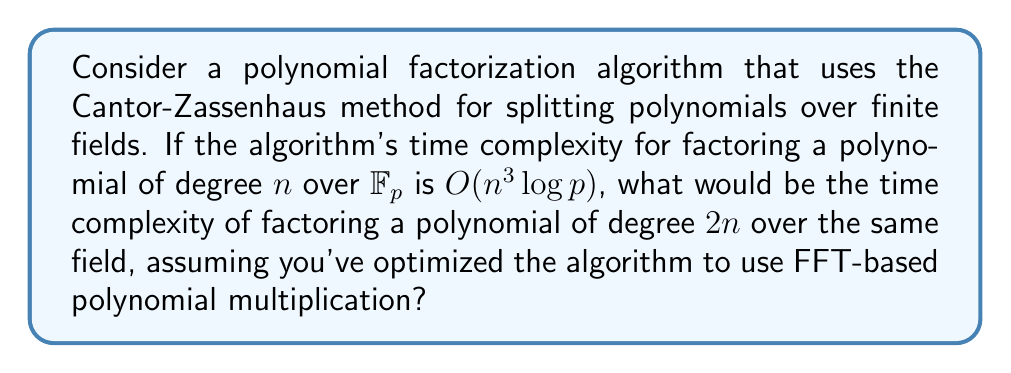What is the answer to this math problem? Let's approach this step-by-step:

1) The original time complexity is $O(n^3 \log p)$ for a polynomial of degree $n$.

2) When we double the degree to $2n$, we need to consider how this affects each part of the algorithm:

   a) The number of iterations in the Cantor-Zassenhaus method is proportional to the degree, so this factor becomes $2n$.

   b) Each iteration involves polynomial arithmetic, primarily multiplication and division.

3) The key optimization mentioned is the use of FFT-based polynomial multiplication. This reduces the complexity of polynomial multiplication from $O(n^2)$ to $O(n \log n)$.

4) In the context of OCaml, this optimization could be implemented using efficient FFT libraries or custom implementations tailored for polynomial arithmetic.

5) With this optimization, the dominant operations in each iteration now have complexity $O(n \log n)$ instead of $O(n^2)$.

6) Therefore, the new time complexity can be estimated as:

   $O((2n)^2 \log(2n) \log p)$

7) Simplifying:
   $O(4n^2 \log(2n) \log p)$
   $= O(n^2 \log n \log p)$

8) The constant factors and the $\log 2$ term can be absorbed into the big-O notation.

Thus, the optimized algorithm for a polynomial of degree $2n$ has a time complexity of $O(n^2 \log n \log p)$.
Answer: $O(n^2 \log n \log p)$ 